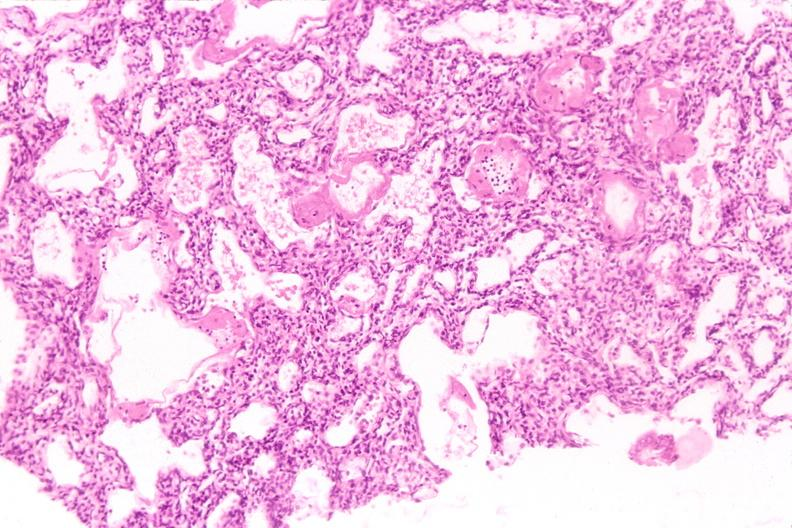s respiratory present?
Answer the question using a single word or phrase. Yes 